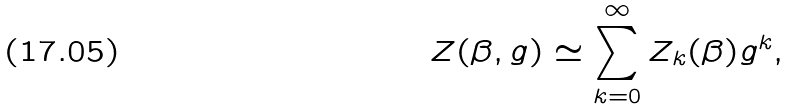Convert formula to latex. <formula><loc_0><loc_0><loc_500><loc_500>Z ( \beta , g ) \simeq \sum _ { k = 0 } ^ { \infty } Z _ { k } ( \beta ) g ^ { k } ,</formula> 